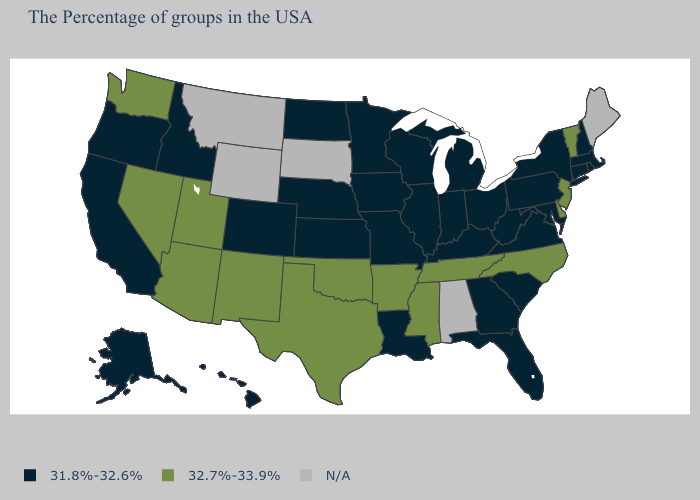What is the value of Nevada?
Answer briefly. 32.7%-33.9%. Name the states that have a value in the range 32.7%-33.9%?
Be succinct. Vermont, New Jersey, Delaware, North Carolina, Tennessee, Mississippi, Arkansas, Oklahoma, Texas, New Mexico, Utah, Arizona, Nevada, Washington. Does Idaho have the lowest value in the West?
Quick response, please. Yes. Does the map have missing data?
Write a very short answer. Yes. Name the states that have a value in the range 31.8%-32.6%?
Concise answer only. Massachusetts, Rhode Island, New Hampshire, Connecticut, New York, Maryland, Pennsylvania, Virginia, South Carolina, West Virginia, Ohio, Florida, Georgia, Michigan, Kentucky, Indiana, Wisconsin, Illinois, Louisiana, Missouri, Minnesota, Iowa, Kansas, Nebraska, North Dakota, Colorado, Idaho, California, Oregon, Alaska, Hawaii. Is the legend a continuous bar?
Be succinct. No. What is the lowest value in states that border Minnesota?
Short answer required. 31.8%-32.6%. Among the states that border Pennsylvania , which have the highest value?
Be succinct. New Jersey, Delaware. Is the legend a continuous bar?
Answer briefly. No. Name the states that have a value in the range 31.8%-32.6%?
Keep it brief. Massachusetts, Rhode Island, New Hampshire, Connecticut, New York, Maryland, Pennsylvania, Virginia, South Carolina, West Virginia, Ohio, Florida, Georgia, Michigan, Kentucky, Indiana, Wisconsin, Illinois, Louisiana, Missouri, Minnesota, Iowa, Kansas, Nebraska, North Dakota, Colorado, Idaho, California, Oregon, Alaska, Hawaii. Does the map have missing data?
Be succinct. Yes. Does the first symbol in the legend represent the smallest category?
Quick response, please. Yes. Is the legend a continuous bar?
Keep it brief. No. What is the highest value in states that border South Carolina?
Give a very brief answer. 32.7%-33.9%. 